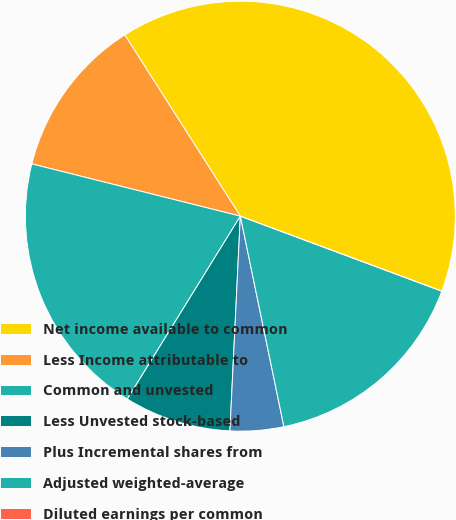<chart> <loc_0><loc_0><loc_500><loc_500><pie_chart><fcel>Net income available to common<fcel>Less Income attributable to<fcel>Common and unvested<fcel>Less Unvested stock-based<fcel>Plus Incremental shares from<fcel>Adjusted weighted-average<fcel>Diluted earnings per common<nl><fcel>39.71%<fcel>12.06%<fcel>20.1%<fcel>8.04%<fcel>4.02%<fcel>16.08%<fcel>0.0%<nl></chart> 